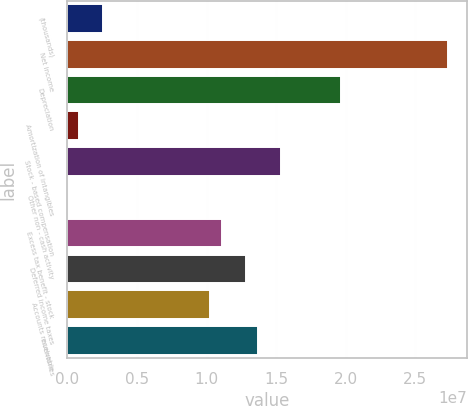Convert chart to OTSL. <chart><loc_0><loc_0><loc_500><loc_500><bar_chart><fcel>(thousands)<fcel>Net income<fcel>Depreciation<fcel>Amortization of intangibles<fcel>Stock - based compensation<fcel>Other non - cash activity<fcel>Excess tax benefit - stock<fcel>Deferred income taxes<fcel>Accounts receivable<fcel>Inventories<nl><fcel>2.56223e+06<fcel>2.73287e+07<fcel>1.96425e+07<fcel>854200<fcel>1.53725e+07<fcel>185<fcel>1.11024e+07<fcel>1.28104e+07<fcel>1.02484e+07<fcel>1.36644e+07<nl></chart> 